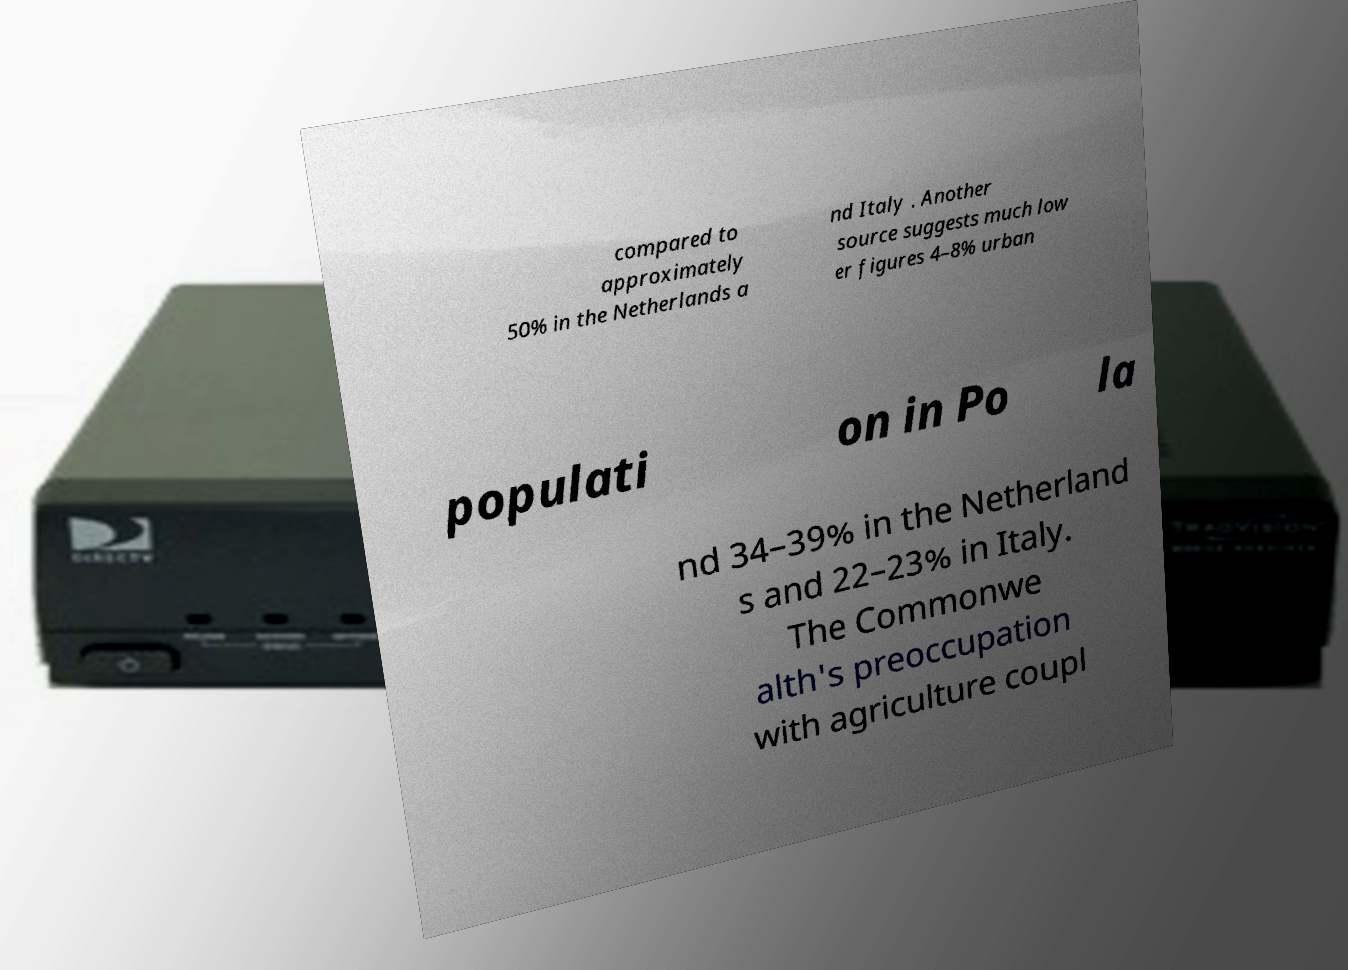Could you assist in decoding the text presented in this image and type it out clearly? compared to approximately 50% in the Netherlands a nd Italy . Another source suggests much low er figures 4–8% urban populati on in Po la nd 34–39% in the Netherland s and 22–23% in Italy. The Commonwe alth's preoccupation with agriculture coupl 